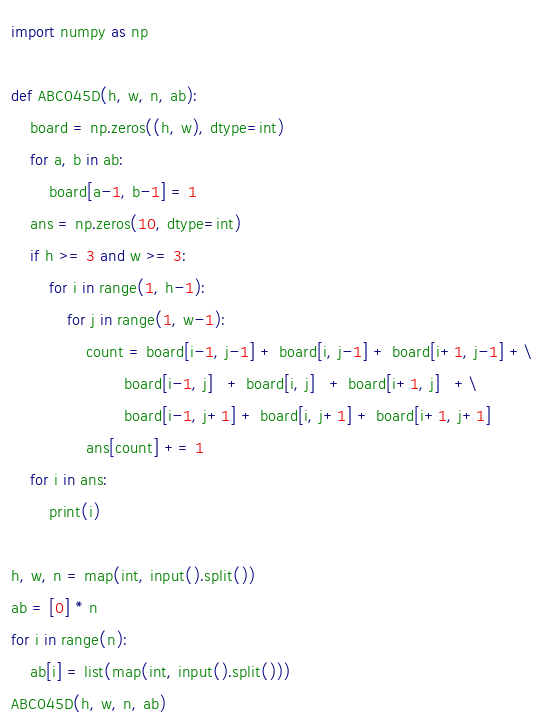Convert code to text. <code><loc_0><loc_0><loc_500><loc_500><_Python_>import numpy as np

def ABC045D(h, w, n, ab):
    board = np.zeros((h, w), dtype=int)
    for a, b in ab:
        board[a-1, b-1] = 1
    ans = np.zeros(10, dtype=int)
    if h >= 3 and w >= 3:
        for i in range(1, h-1):
            for j in range(1, w-1):
                count = board[i-1, j-1] + board[i, j-1] + board[i+1, j-1] +\
                        board[i-1, j]   + board[i, j]   + board[i+1, j]   +\
                        board[i-1, j+1] + board[i, j+1] + board[i+1, j+1]
                ans[count] += 1
    for i in ans:
        print(i)

h, w, n = map(int, input().split())
ab = [0] * n
for i in range(n):
    ab[i] = list(map(int, input().split()))
ABC045D(h, w, n, ab)
</code> 